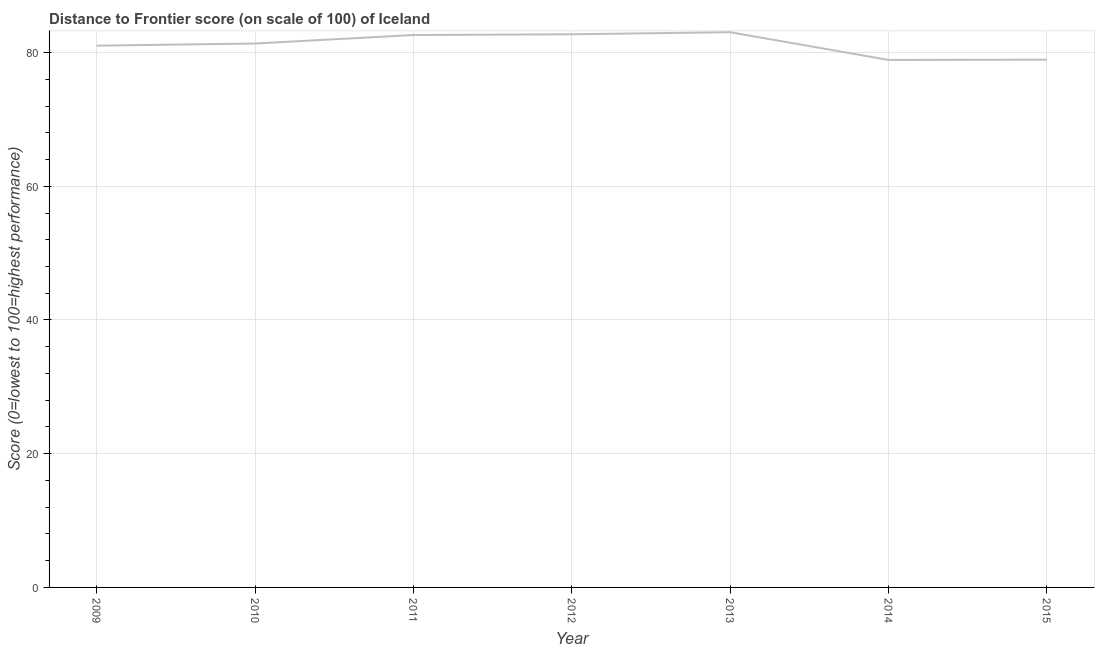What is the distance to frontier score in 2009?
Your answer should be very brief. 81.03. Across all years, what is the maximum distance to frontier score?
Your answer should be compact. 83.04. Across all years, what is the minimum distance to frontier score?
Your response must be concise. 78.89. In which year was the distance to frontier score maximum?
Keep it short and to the point. 2013. What is the sum of the distance to frontier score?
Provide a short and direct response. 568.59. What is the difference between the distance to frontier score in 2012 and 2013?
Provide a short and direct response. -0.31. What is the average distance to frontier score per year?
Your answer should be compact. 81.23. What is the median distance to frontier score?
Your answer should be compact. 81.35. In how many years, is the distance to frontier score greater than 36 ?
Offer a very short reply. 7. Do a majority of the years between 2015 and 2014 (inclusive) have distance to frontier score greater than 24 ?
Give a very brief answer. No. What is the ratio of the distance to frontier score in 2010 to that in 2015?
Offer a terse response. 1.03. Is the difference between the distance to frontier score in 2010 and 2011 greater than the difference between any two years?
Give a very brief answer. No. What is the difference between the highest and the second highest distance to frontier score?
Your answer should be very brief. 0.31. What is the difference between the highest and the lowest distance to frontier score?
Offer a very short reply. 4.15. Does the distance to frontier score monotonically increase over the years?
Your answer should be very brief. No. How many years are there in the graph?
Your answer should be compact. 7. Are the values on the major ticks of Y-axis written in scientific E-notation?
Keep it short and to the point. No. Does the graph contain any zero values?
Give a very brief answer. No. What is the title of the graph?
Provide a succinct answer. Distance to Frontier score (on scale of 100) of Iceland. What is the label or title of the Y-axis?
Your answer should be very brief. Score (0=lowest to 100=highest performance). What is the Score (0=lowest to 100=highest performance) in 2009?
Your answer should be very brief. 81.03. What is the Score (0=lowest to 100=highest performance) in 2010?
Your answer should be very brief. 81.35. What is the Score (0=lowest to 100=highest performance) in 2011?
Ensure brevity in your answer.  82.62. What is the Score (0=lowest to 100=highest performance) in 2012?
Provide a succinct answer. 82.73. What is the Score (0=lowest to 100=highest performance) of 2013?
Offer a very short reply. 83.04. What is the Score (0=lowest to 100=highest performance) of 2014?
Your response must be concise. 78.89. What is the Score (0=lowest to 100=highest performance) in 2015?
Give a very brief answer. 78.93. What is the difference between the Score (0=lowest to 100=highest performance) in 2009 and 2010?
Your answer should be compact. -0.32. What is the difference between the Score (0=lowest to 100=highest performance) in 2009 and 2011?
Offer a very short reply. -1.59. What is the difference between the Score (0=lowest to 100=highest performance) in 2009 and 2012?
Offer a very short reply. -1.7. What is the difference between the Score (0=lowest to 100=highest performance) in 2009 and 2013?
Offer a very short reply. -2.01. What is the difference between the Score (0=lowest to 100=highest performance) in 2009 and 2014?
Ensure brevity in your answer.  2.14. What is the difference between the Score (0=lowest to 100=highest performance) in 2010 and 2011?
Offer a terse response. -1.27. What is the difference between the Score (0=lowest to 100=highest performance) in 2010 and 2012?
Your answer should be compact. -1.38. What is the difference between the Score (0=lowest to 100=highest performance) in 2010 and 2013?
Your response must be concise. -1.69. What is the difference between the Score (0=lowest to 100=highest performance) in 2010 and 2014?
Offer a very short reply. 2.46. What is the difference between the Score (0=lowest to 100=highest performance) in 2010 and 2015?
Your response must be concise. 2.42. What is the difference between the Score (0=lowest to 100=highest performance) in 2011 and 2012?
Ensure brevity in your answer.  -0.11. What is the difference between the Score (0=lowest to 100=highest performance) in 2011 and 2013?
Ensure brevity in your answer.  -0.42. What is the difference between the Score (0=lowest to 100=highest performance) in 2011 and 2014?
Your answer should be compact. 3.73. What is the difference between the Score (0=lowest to 100=highest performance) in 2011 and 2015?
Your answer should be very brief. 3.69. What is the difference between the Score (0=lowest to 100=highest performance) in 2012 and 2013?
Provide a succinct answer. -0.31. What is the difference between the Score (0=lowest to 100=highest performance) in 2012 and 2014?
Offer a terse response. 3.84. What is the difference between the Score (0=lowest to 100=highest performance) in 2013 and 2014?
Offer a very short reply. 4.15. What is the difference between the Score (0=lowest to 100=highest performance) in 2013 and 2015?
Offer a terse response. 4.11. What is the difference between the Score (0=lowest to 100=highest performance) in 2014 and 2015?
Ensure brevity in your answer.  -0.04. What is the ratio of the Score (0=lowest to 100=highest performance) in 2009 to that in 2012?
Keep it short and to the point. 0.98. What is the ratio of the Score (0=lowest to 100=highest performance) in 2009 to that in 2014?
Your answer should be very brief. 1.03. What is the ratio of the Score (0=lowest to 100=highest performance) in 2009 to that in 2015?
Provide a succinct answer. 1.03. What is the ratio of the Score (0=lowest to 100=highest performance) in 2010 to that in 2012?
Keep it short and to the point. 0.98. What is the ratio of the Score (0=lowest to 100=highest performance) in 2010 to that in 2014?
Provide a succinct answer. 1.03. What is the ratio of the Score (0=lowest to 100=highest performance) in 2010 to that in 2015?
Offer a terse response. 1.03. What is the ratio of the Score (0=lowest to 100=highest performance) in 2011 to that in 2012?
Give a very brief answer. 1. What is the ratio of the Score (0=lowest to 100=highest performance) in 2011 to that in 2014?
Provide a succinct answer. 1.05. What is the ratio of the Score (0=lowest to 100=highest performance) in 2011 to that in 2015?
Keep it short and to the point. 1.05. What is the ratio of the Score (0=lowest to 100=highest performance) in 2012 to that in 2013?
Make the answer very short. 1. What is the ratio of the Score (0=lowest to 100=highest performance) in 2012 to that in 2014?
Your answer should be very brief. 1.05. What is the ratio of the Score (0=lowest to 100=highest performance) in 2012 to that in 2015?
Offer a terse response. 1.05. What is the ratio of the Score (0=lowest to 100=highest performance) in 2013 to that in 2014?
Make the answer very short. 1.05. What is the ratio of the Score (0=lowest to 100=highest performance) in 2013 to that in 2015?
Offer a terse response. 1.05. What is the ratio of the Score (0=lowest to 100=highest performance) in 2014 to that in 2015?
Your answer should be compact. 1. 